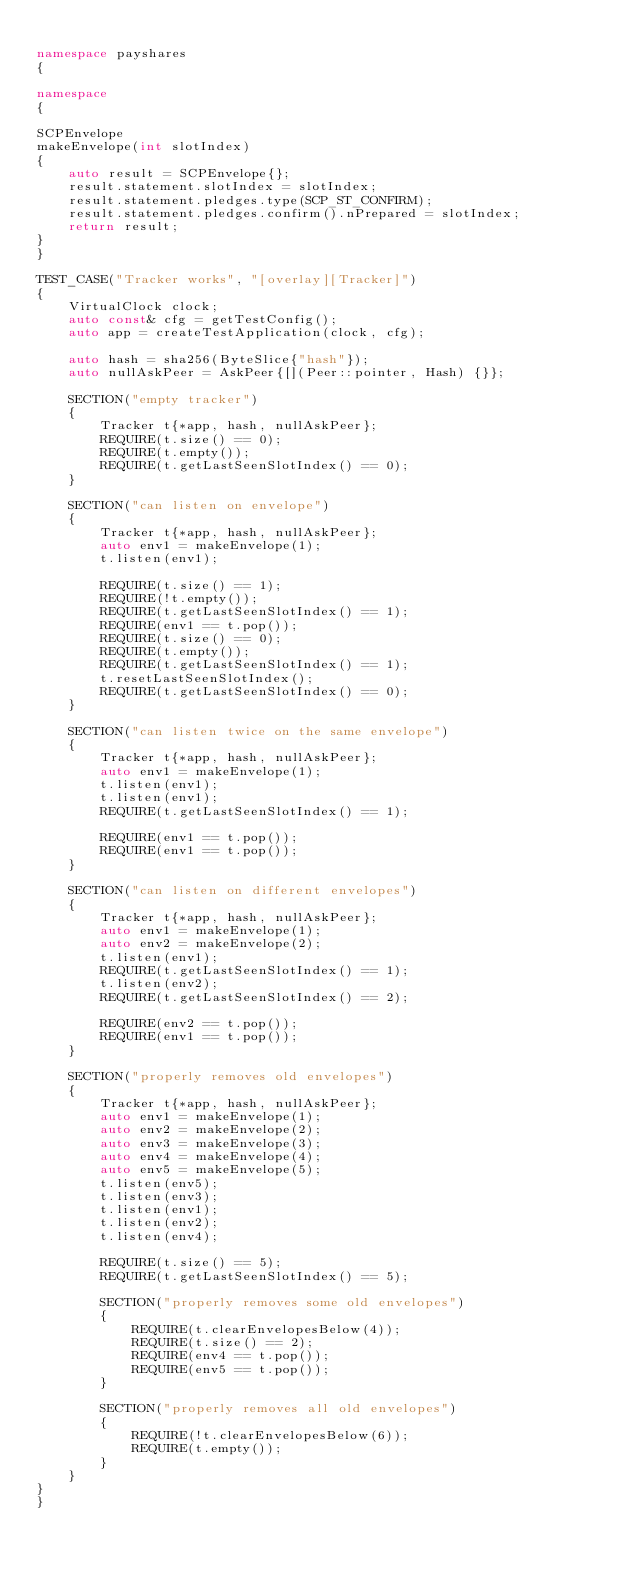<code> <loc_0><loc_0><loc_500><loc_500><_C++_>
namespace payshares
{

namespace
{

SCPEnvelope
makeEnvelope(int slotIndex)
{
    auto result = SCPEnvelope{};
    result.statement.slotIndex = slotIndex;
    result.statement.pledges.type(SCP_ST_CONFIRM);
    result.statement.pledges.confirm().nPrepared = slotIndex;
    return result;
}
}

TEST_CASE("Tracker works", "[overlay][Tracker]")
{
    VirtualClock clock;
    auto const& cfg = getTestConfig();
    auto app = createTestApplication(clock, cfg);

    auto hash = sha256(ByteSlice{"hash"});
    auto nullAskPeer = AskPeer{[](Peer::pointer, Hash) {}};

    SECTION("empty tracker")
    {
        Tracker t{*app, hash, nullAskPeer};
        REQUIRE(t.size() == 0);
        REQUIRE(t.empty());
        REQUIRE(t.getLastSeenSlotIndex() == 0);
    }

    SECTION("can listen on envelope")
    {
        Tracker t{*app, hash, nullAskPeer};
        auto env1 = makeEnvelope(1);
        t.listen(env1);

        REQUIRE(t.size() == 1);
        REQUIRE(!t.empty());
        REQUIRE(t.getLastSeenSlotIndex() == 1);
        REQUIRE(env1 == t.pop());
        REQUIRE(t.size() == 0);
        REQUIRE(t.empty());
        REQUIRE(t.getLastSeenSlotIndex() == 1);
        t.resetLastSeenSlotIndex();
        REQUIRE(t.getLastSeenSlotIndex() == 0);
    }

    SECTION("can listen twice on the same envelope")
    {
        Tracker t{*app, hash, nullAskPeer};
        auto env1 = makeEnvelope(1);
        t.listen(env1);
        t.listen(env1);
        REQUIRE(t.getLastSeenSlotIndex() == 1);

        REQUIRE(env1 == t.pop());
        REQUIRE(env1 == t.pop());
    }

    SECTION("can listen on different envelopes")
    {
        Tracker t{*app, hash, nullAskPeer};
        auto env1 = makeEnvelope(1);
        auto env2 = makeEnvelope(2);
        t.listen(env1);
        REQUIRE(t.getLastSeenSlotIndex() == 1);
        t.listen(env2);
        REQUIRE(t.getLastSeenSlotIndex() == 2);

        REQUIRE(env2 == t.pop());
        REQUIRE(env1 == t.pop());
    }

    SECTION("properly removes old envelopes")
    {
        Tracker t{*app, hash, nullAskPeer};
        auto env1 = makeEnvelope(1);
        auto env2 = makeEnvelope(2);
        auto env3 = makeEnvelope(3);
        auto env4 = makeEnvelope(4);
        auto env5 = makeEnvelope(5);
        t.listen(env5);
        t.listen(env3);
        t.listen(env1);
        t.listen(env2);
        t.listen(env4);

        REQUIRE(t.size() == 5);
        REQUIRE(t.getLastSeenSlotIndex() == 5);

        SECTION("properly removes some old envelopes")
        {
            REQUIRE(t.clearEnvelopesBelow(4));
            REQUIRE(t.size() == 2);
            REQUIRE(env4 == t.pop());
            REQUIRE(env5 == t.pop());
        }

        SECTION("properly removes all old envelopes")
        {
            REQUIRE(!t.clearEnvelopesBelow(6));
            REQUIRE(t.empty());
        }
    }
}
}
</code> 